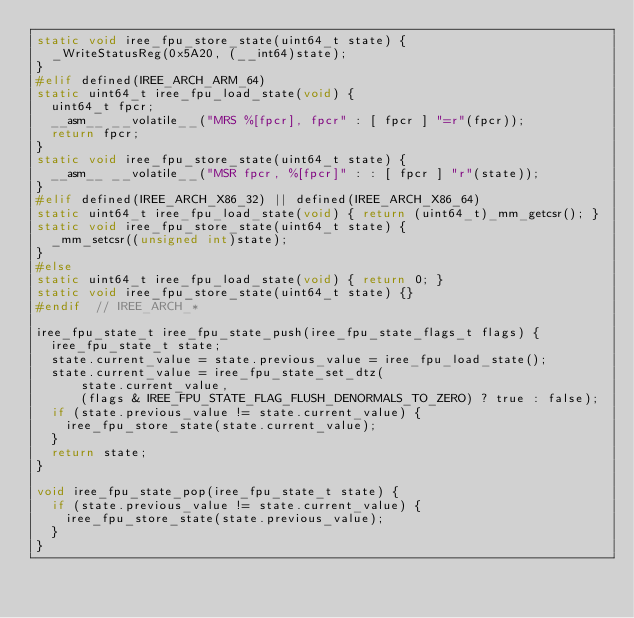<code> <loc_0><loc_0><loc_500><loc_500><_C_>static void iree_fpu_store_state(uint64_t state) {
  _WriteStatusReg(0x5A20, (__int64)state);
}
#elif defined(IREE_ARCH_ARM_64)
static uint64_t iree_fpu_load_state(void) {
  uint64_t fpcr;
  __asm__ __volatile__("MRS %[fpcr], fpcr" : [ fpcr ] "=r"(fpcr));
  return fpcr;
}
static void iree_fpu_store_state(uint64_t state) {
  __asm__ __volatile__("MSR fpcr, %[fpcr]" : : [ fpcr ] "r"(state));
}
#elif defined(IREE_ARCH_X86_32) || defined(IREE_ARCH_X86_64)
static uint64_t iree_fpu_load_state(void) { return (uint64_t)_mm_getcsr(); }
static void iree_fpu_store_state(uint64_t state) {
  _mm_setcsr((unsigned int)state);
}
#else
static uint64_t iree_fpu_load_state(void) { return 0; }
static void iree_fpu_store_state(uint64_t state) {}
#endif  // IREE_ARCH_*

iree_fpu_state_t iree_fpu_state_push(iree_fpu_state_flags_t flags) {
  iree_fpu_state_t state;
  state.current_value = state.previous_value = iree_fpu_load_state();
  state.current_value = iree_fpu_state_set_dtz(
      state.current_value,
      (flags & IREE_FPU_STATE_FLAG_FLUSH_DENORMALS_TO_ZERO) ? true : false);
  if (state.previous_value != state.current_value) {
    iree_fpu_store_state(state.current_value);
  }
  return state;
}

void iree_fpu_state_pop(iree_fpu_state_t state) {
  if (state.previous_value != state.current_value) {
    iree_fpu_store_state(state.previous_value);
  }
}
</code> 